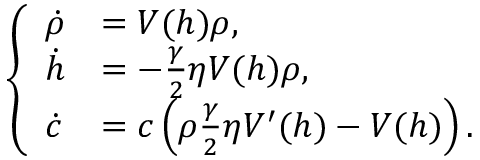Convert formula to latex. <formula><loc_0><loc_0><loc_500><loc_500>\begin{array} { r } { \left \{ \begin{array} { l l } { \dot { \rho } } & { = V ( h ) \rho , } \\ { \dot { h } } & { = - \frac { \gamma } { 2 } \eta V ( h ) \rho , } \\ { \dot { c } } & { = c \left ( \rho \frac { \gamma } { 2 } \eta V ^ { \prime } ( h ) - V ( h ) \right ) . } \end{array} } \end{array}</formula> 